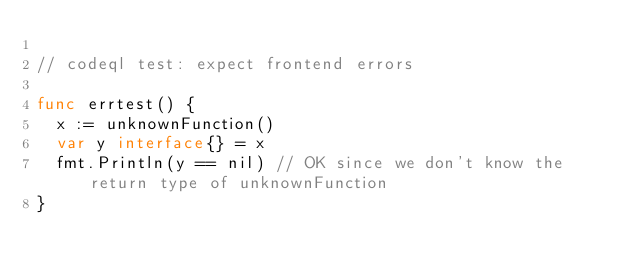Convert code to text. <code><loc_0><loc_0><loc_500><loc_500><_Go_>
// codeql test: expect frontend errors

func errtest() {
	x := unknownFunction()
	var y interface{} = x
	fmt.Println(y == nil) // OK since we don't know the return type of unknownFunction
}
</code> 